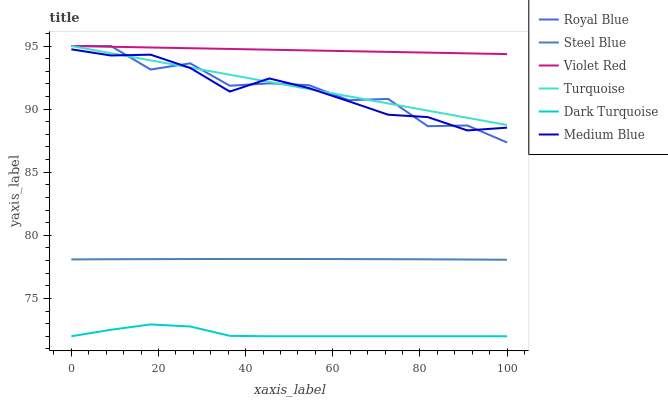Does Medium Blue have the minimum area under the curve?
Answer yes or no. No. Does Medium Blue have the maximum area under the curve?
Answer yes or no. No. Is Dark Turquoise the smoothest?
Answer yes or no. No. Is Dark Turquoise the roughest?
Answer yes or no. No. Does Medium Blue have the lowest value?
Answer yes or no. No. Does Medium Blue have the highest value?
Answer yes or no. No. Is Dark Turquoise less than Royal Blue?
Answer yes or no. Yes. Is Royal Blue greater than Steel Blue?
Answer yes or no. Yes. Does Dark Turquoise intersect Royal Blue?
Answer yes or no. No. 